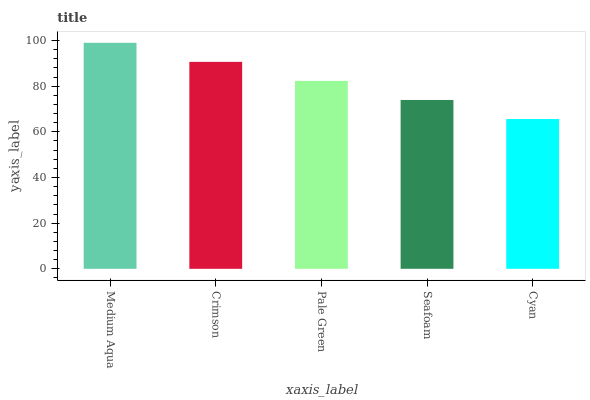Is Cyan the minimum?
Answer yes or no. Yes. Is Medium Aqua the maximum?
Answer yes or no. Yes. Is Crimson the minimum?
Answer yes or no. No. Is Crimson the maximum?
Answer yes or no. No. Is Medium Aqua greater than Crimson?
Answer yes or no. Yes. Is Crimson less than Medium Aqua?
Answer yes or no. Yes. Is Crimson greater than Medium Aqua?
Answer yes or no. No. Is Medium Aqua less than Crimson?
Answer yes or no. No. Is Pale Green the high median?
Answer yes or no. Yes. Is Pale Green the low median?
Answer yes or no. Yes. Is Cyan the high median?
Answer yes or no. No. Is Cyan the low median?
Answer yes or no. No. 